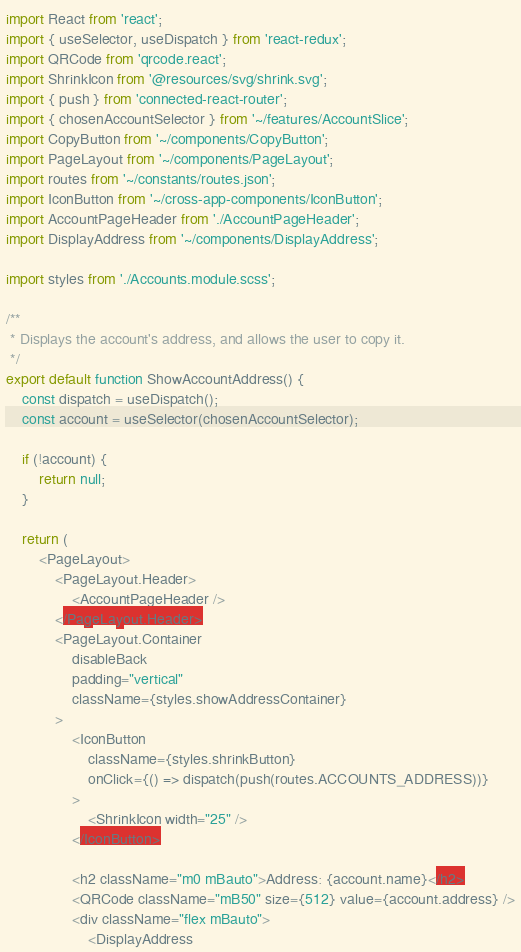<code> <loc_0><loc_0><loc_500><loc_500><_TypeScript_>import React from 'react';
import { useSelector, useDispatch } from 'react-redux';
import QRCode from 'qrcode.react';
import ShrinkIcon from '@resources/svg/shrink.svg';
import { push } from 'connected-react-router';
import { chosenAccountSelector } from '~/features/AccountSlice';
import CopyButton from '~/components/CopyButton';
import PageLayout from '~/components/PageLayout';
import routes from '~/constants/routes.json';
import IconButton from '~/cross-app-components/IconButton';
import AccountPageHeader from './AccountPageHeader';
import DisplayAddress from '~/components/DisplayAddress';

import styles from './Accounts.module.scss';

/**
 * Displays the account's address, and allows the user to copy it.
 */
export default function ShowAccountAddress() {
    const dispatch = useDispatch();
    const account = useSelector(chosenAccountSelector);

    if (!account) {
        return null;
    }

    return (
        <PageLayout>
            <PageLayout.Header>
                <AccountPageHeader />
            </PageLayout.Header>
            <PageLayout.Container
                disableBack
                padding="vertical"
                className={styles.showAddressContainer}
            >
                <IconButton
                    className={styles.shrinkButton}
                    onClick={() => dispatch(push(routes.ACCOUNTS_ADDRESS))}
                >
                    <ShrinkIcon width="25" />
                </IconButton>

                <h2 className="m0 mBauto">Address: {account.name}</h2>
                <QRCode className="mB50" size={512} value={account.address} />
                <div className="flex mBauto">
                    <DisplayAddress</code> 